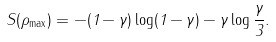Convert formula to latex. <formula><loc_0><loc_0><loc_500><loc_500>S ( \rho _ { \max } ) = - ( 1 - \gamma ) \log ( 1 - \gamma ) - \gamma \log \frac { \gamma } { 3 } .</formula> 